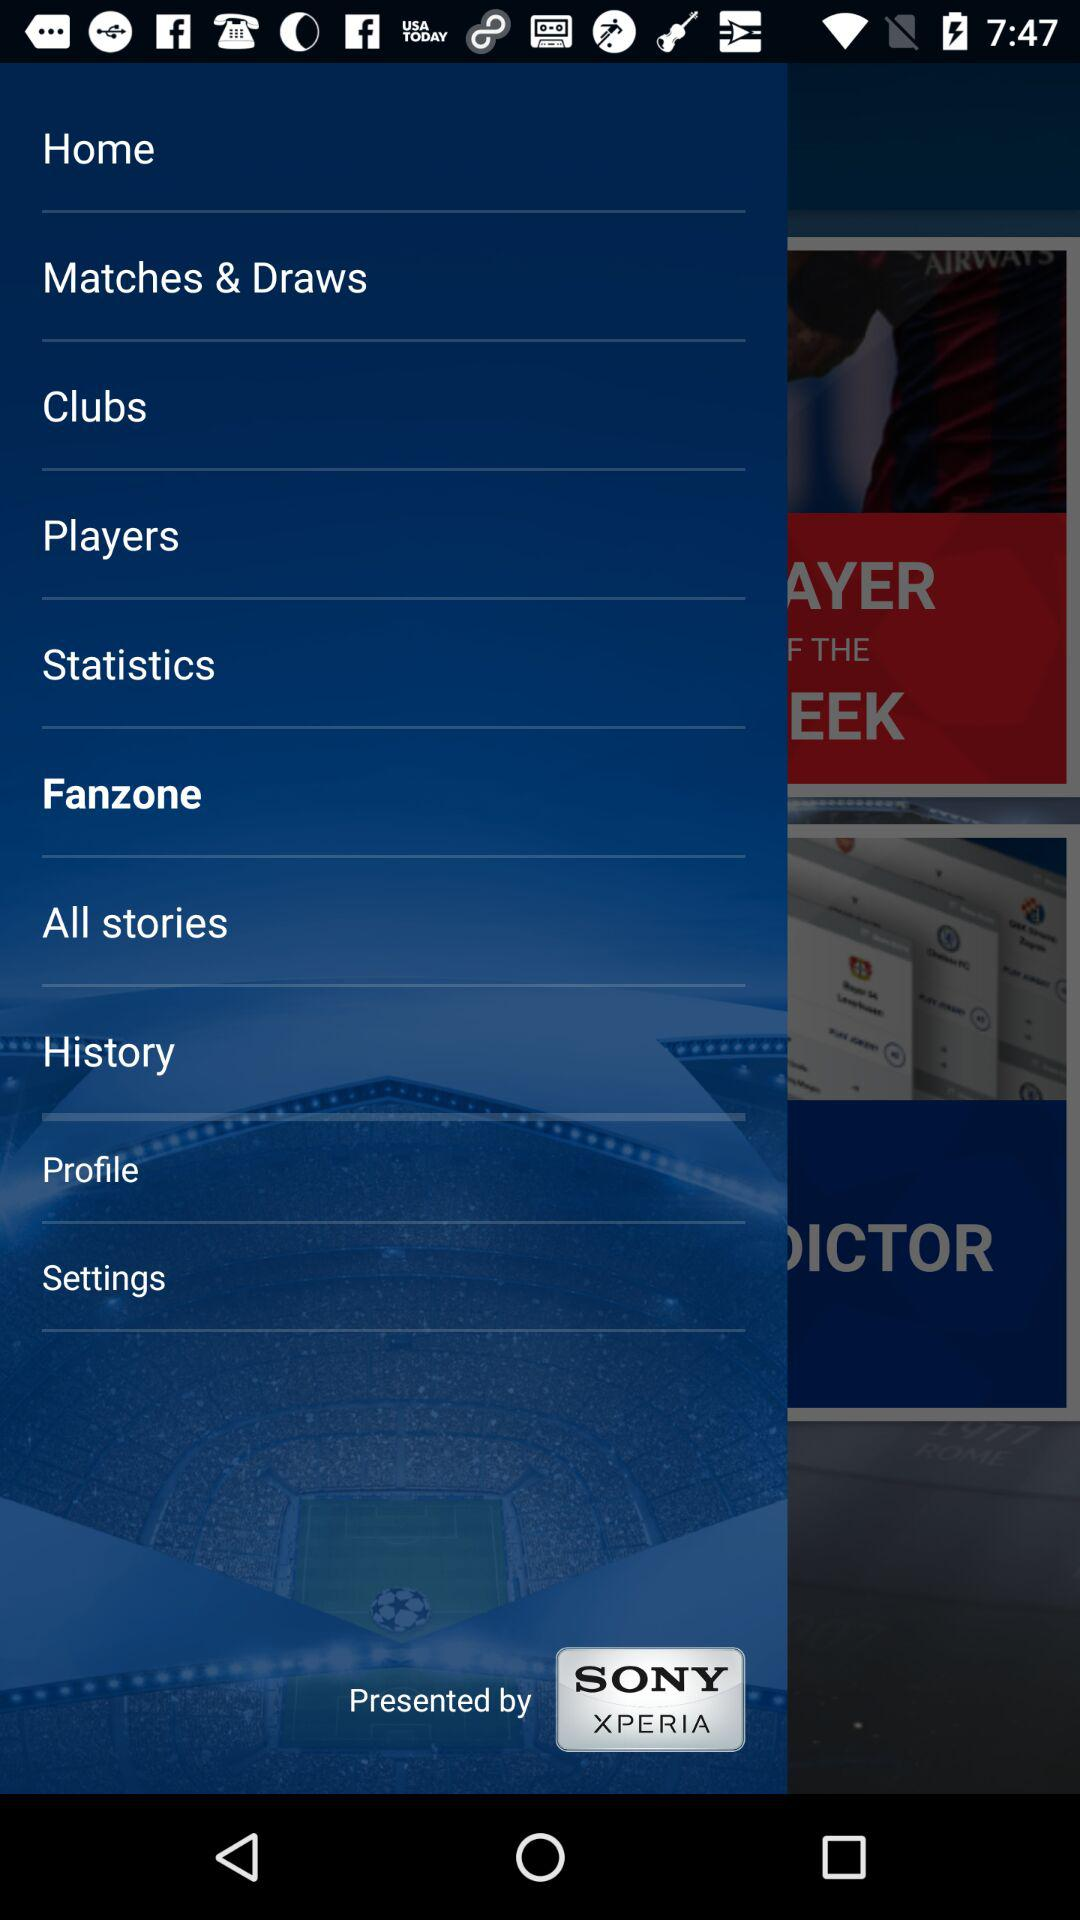By whom is it presented? It is presented by "SONY XPERIA". 